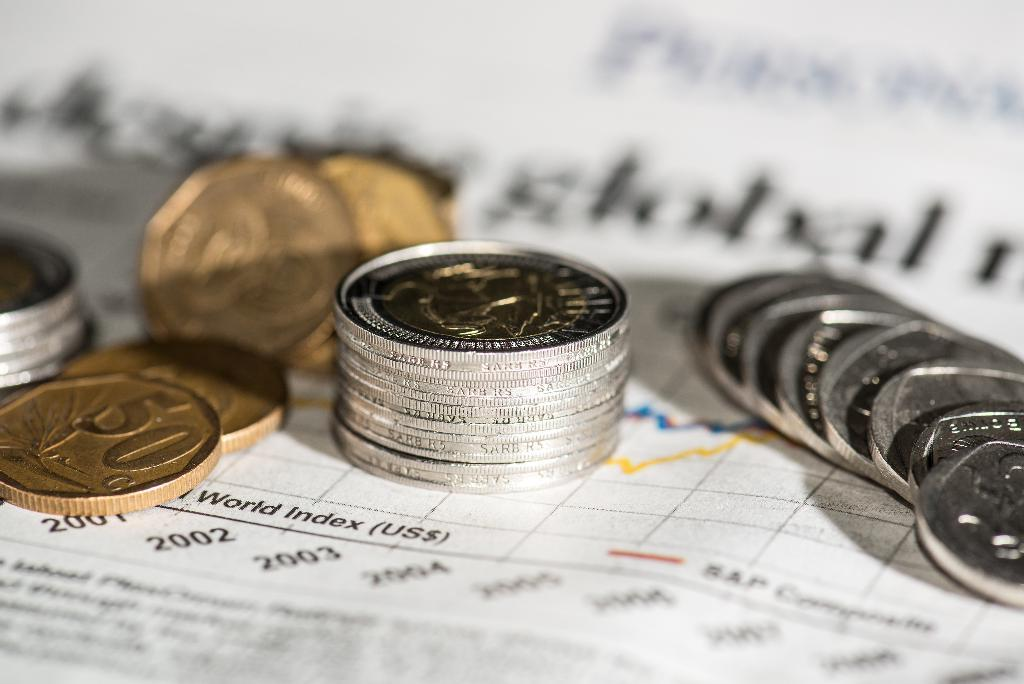<image>
Provide a brief description of the given image. A collection of gold and silver coins, where the gold coin is valued at 50. 